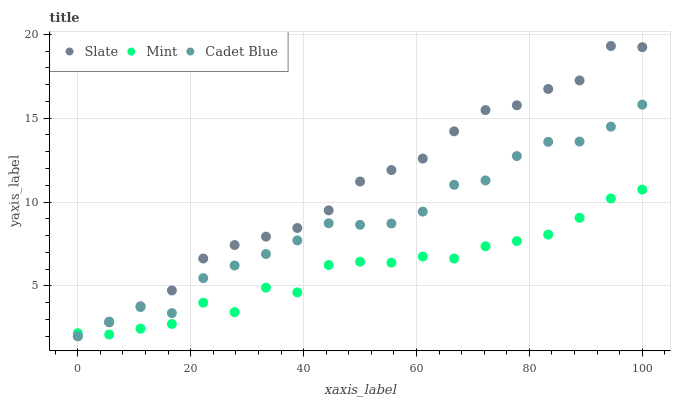Does Mint have the minimum area under the curve?
Answer yes or no. Yes. Does Slate have the maximum area under the curve?
Answer yes or no. Yes. Does Cadet Blue have the minimum area under the curve?
Answer yes or no. No. Does Cadet Blue have the maximum area under the curve?
Answer yes or no. No. Is Slate the smoothest?
Answer yes or no. Yes. Is Mint the roughest?
Answer yes or no. Yes. Is Cadet Blue the smoothest?
Answer yes or no. No. Is Cadet Blue the roughest?
Answer yes or no. No. Does Slate have the lowest value?
Answer yes or no. Yes. Does Mint have the lowest value?
Answer yes or no. No. Does Slate have the highest value?
Answer yes or no. Yes. Does Cadet Blue have the highest value?
Answer yes or no. No. Does Mint intersect Slate?
Answer yes or no. Yes. Is Mint less than Slate?
Answer yes or no. No. Is Mint greater than Slate?
Answer yes or no. No. 